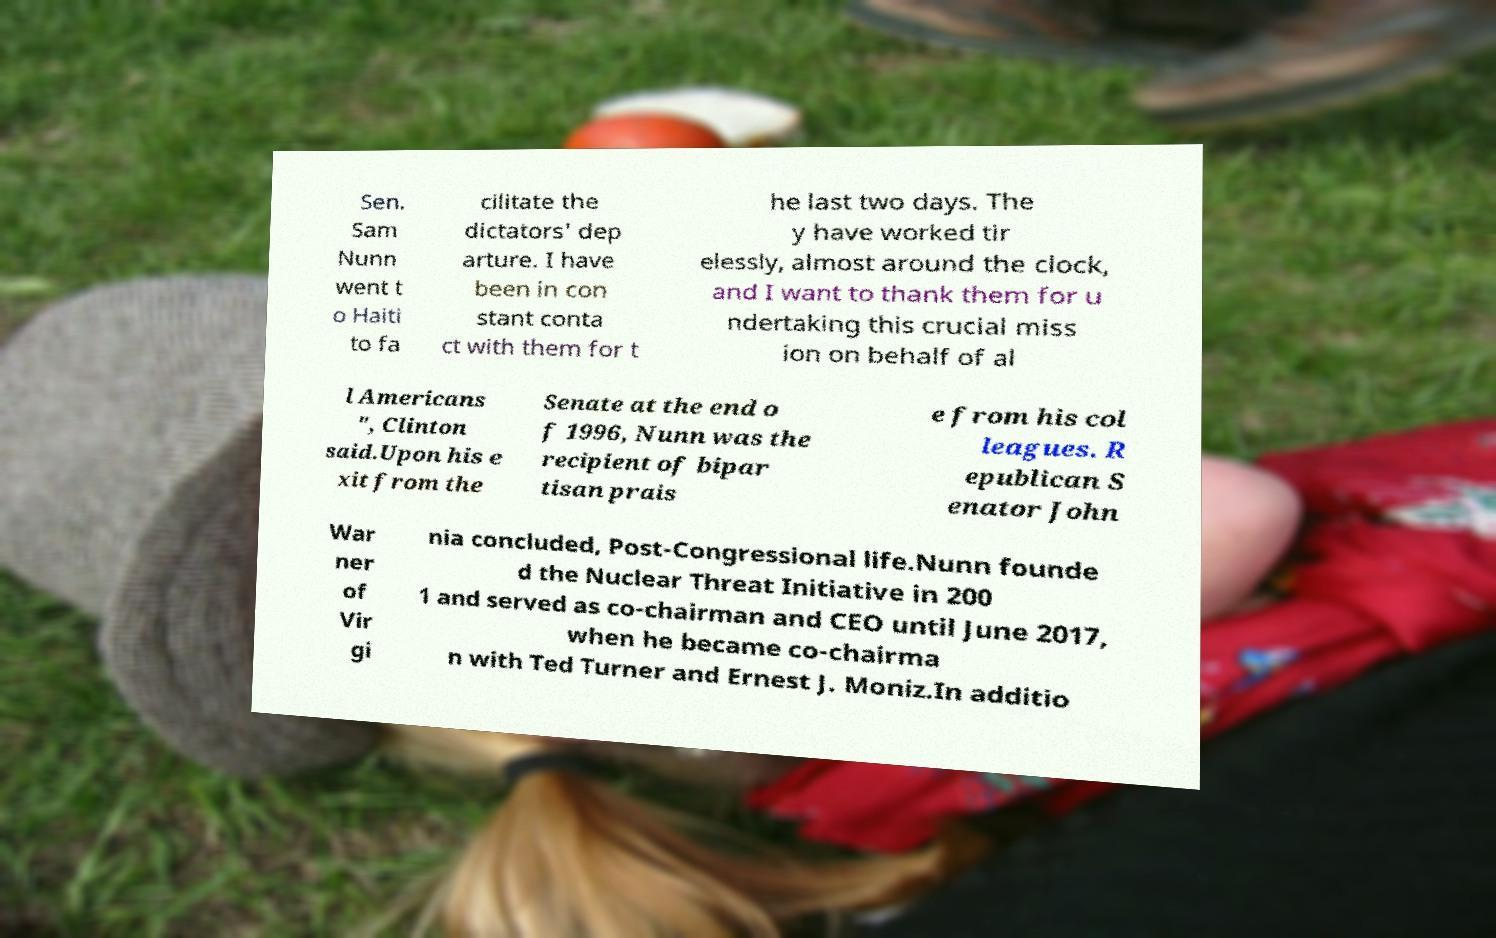What messages or text are displayed in this image? I need them in a readable, typed format. Sen. Sam Nunn went t o Haiti to fa cilitate the dictators' dep arture. I have been in con stant conta ct with them for t he last two days. The y have worked tir elessly, almost around the clock, and I want to thank them for u ndertaking this crucial miss ion on behalf of al l Americans ", Clinton said.Upon his e xit from the Senate at the end o f 1996, Nunn was the recipient of bipar tisan prais e from his col leagues. R epublican S enator John War ner of Vir gi nia concluded, Post-Congressional life.Nunn founde d the Nuclear Threat Initiative in 200 1 and served as co-chairman and CEO until June 2017, when he became co-chairma n with Ted Turner and Ernest J. Moniz.In additio 